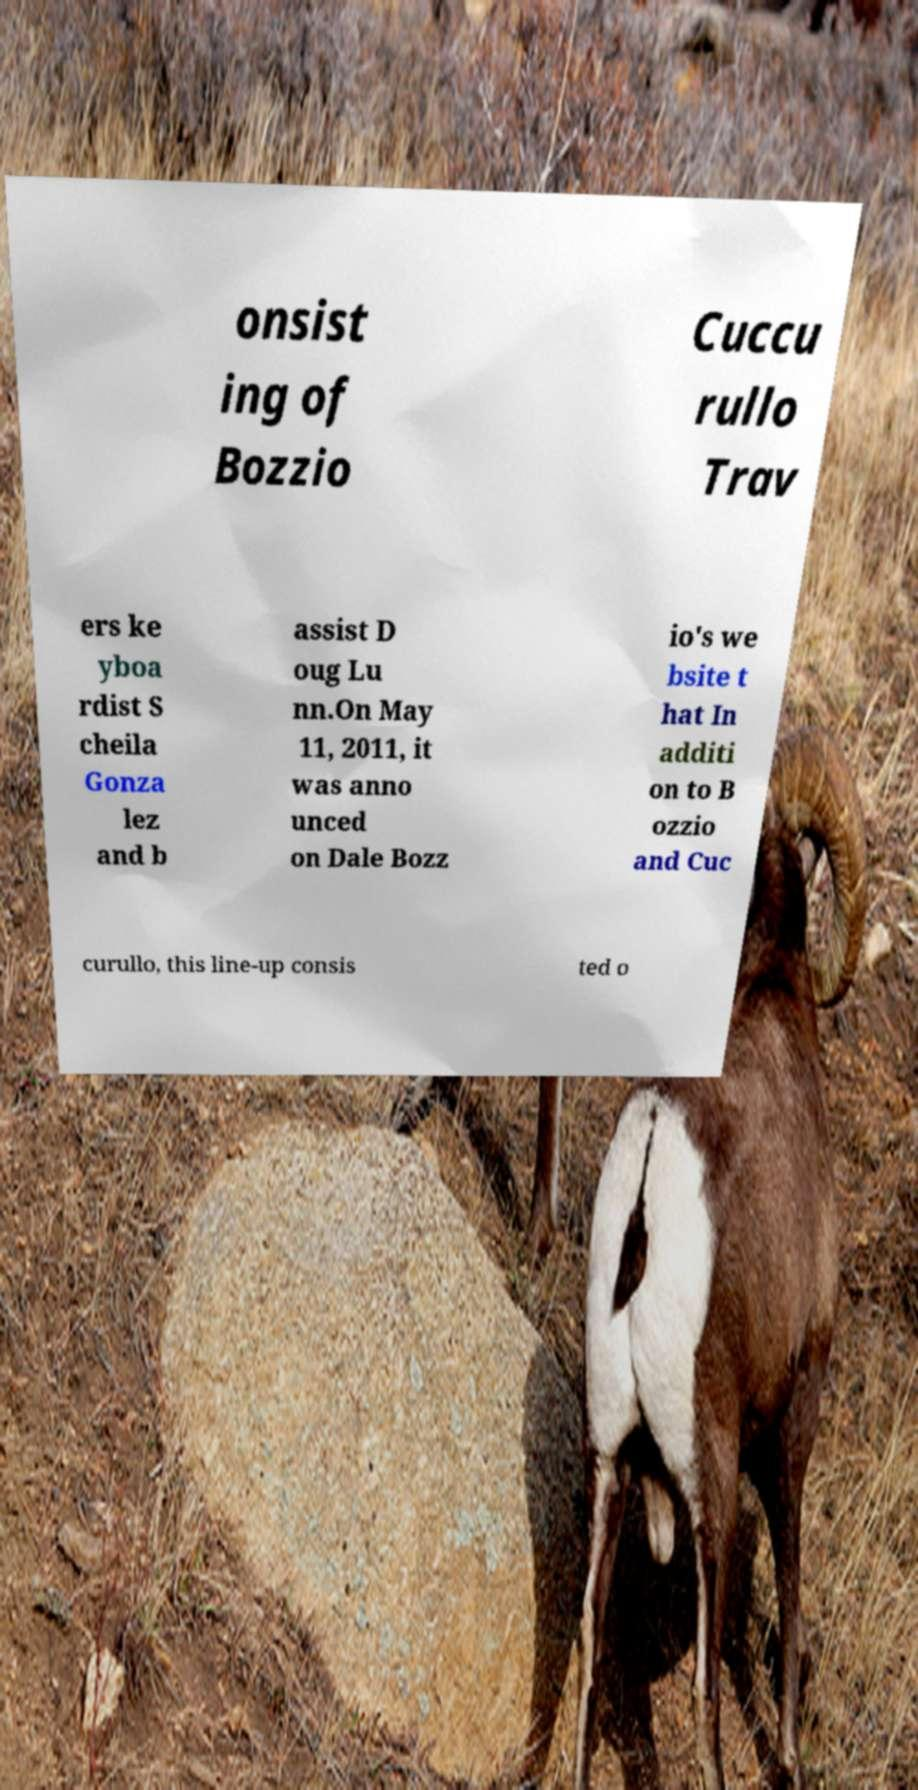For documentation purposes, I need the text within this image transcribed. Could you provide that? onsist ing of Bozzio Cuccu rullo Trav ers ke yboa rdist S cheila Gonza lez and b assist D oug Lu nn.On May 11, 2011, it was anno unced on Dale Bozz io's we bsite t hat In additi on to B ozzio and Cuc curullo, this line-up consis ted o 